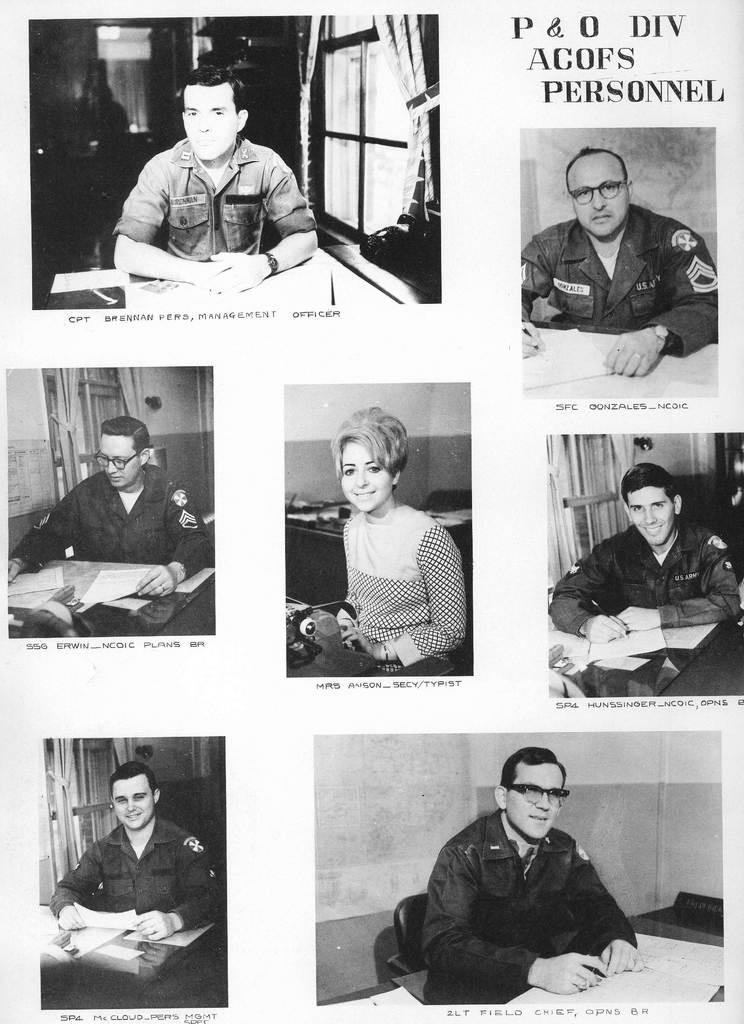Please provide a concise description of this image. We can see photos of people and text. 